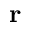<formula> <loc_0><loc_0><loc_500><loc_500>\mathbf r</formula> 